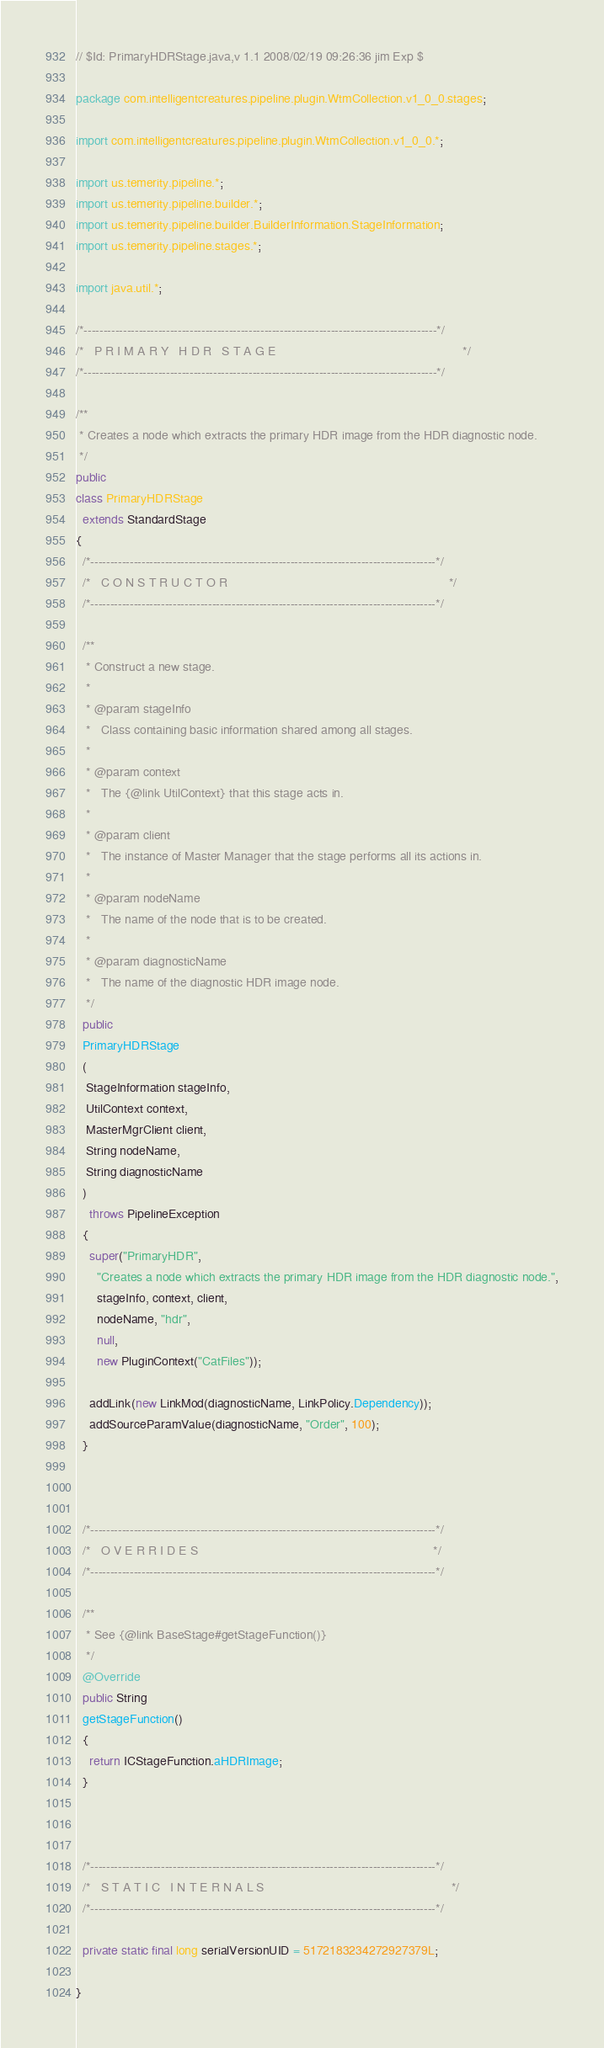Convert code to text. <code><loc_0><loc_0><loc_500><loc_500><_Java_>// $Id: PrimaryHDRStage.java,v 1.1 2008/02/19 09:26:36 jim Exp $

package com.intelligentcreatures.pipeline.plugin.WtmCollection.v1_0_0.stages;

import com.intelligentcreatures.pipeline.plugin.WtmCollection.v1_0_0.*; 

import us.temerity.pipeline.*;
import us.temerity.pipeline.builder.*;
import us.temerity.pipeline.builder.BuilderInformation.StageInformation;
import us.temerity.pipeline.stages.*;

import java.util.*;

/*------------------------------------------------------------------------------------------*/
/*   P R I M A R Y   H D R   S T A G E                                                      */
/*------------------------------------------------------------------------------------------*/

/**
 * Creates a node which extracts the primary HDR image from the HDR diagnostic node.
 */ 
public 
class PrimaryHDRStage 
  extends StandardStage
{
  /*----------------------------------------------------------------------------------------*/
  /*   C O N S T R U C T O R                                                                */
  /*----------------------------------------------------------------------------------------*/

  /**
   * Construct a new stage.
   * 
   * @param stageInfo
   *   Class containing basic information shared among all stages.
   * 
   * @param context
   *   The {@link UtilContext} that this stage acts in.
   * 
   * @param client
   *   The instance of Master Manager that the stage performs all its actions in.
   * 
   * @param nodeName
   *   The name of the node that is to be created.
   * 
   * @param diagnosticName
   *   The name of the diagnostic HDR image node. 
   */
  public
  PrimaryHDRStage
  (
   StageInformation stageInfo,
   UtilContext context,
   MasterMgrClient client, 
   String nodeName, 
   String diagnosticName
  )
    throws PipelineException
  {
    super("PrimaryHDR", 
	  "Creates a node which extracts the primary HDR image from the HDR diagnostic node.",
	  stageInfo, context, client, 
	  nodeName, "hdr", 
	  null, 
	  new PluginContext("CatFiles")); 

    addLink(new LinkMod(diagnosticName, LinkPolicy.Dependency));
    addSourceParamValue(diagnosticName, "Order", 100);
  }
  


  /*----------------------------------------------------------------------------------------*/
  /*   O V E R R I D E S                                                                    */
  /*----------------------------------------------------------------------------------------*/
  
  /**
   * See {@link BaseStage#getStageFunction()}
   */
  @Override
  public String 
  getStageFunction()
  {
    return ICStageFunction.aHDRImage;
  }


   
  /*----------------------------------------------------------------------------------------*/
  /*   S T A T I C   I N T E R N A L S                                                      */
  /*----------------------------------------------------------------------------------------*/
 
  private static final long serialVersionUID = 5172183234272927379L;

}
</code> 